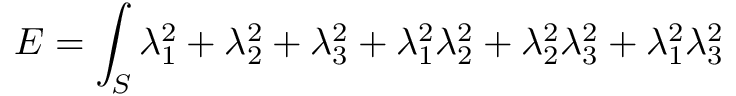Convert formula to latex. <formula><loc_0><loc_0><loc_500><loc_500>E = \int _ { S } \lambda _ { 1 } ^ { 2 } + \lambda _ { 2 } ^ { 2 } + \lambda _ { 3 } ^ { 2 } + \lambda _ { 1 } ^ { 2 } \lambda _ { 2 } ^ { 2 } + \lambda _ { 2 } ^ { 2 } \lambda _ { 3 } ^ { 2 } + \lambda _ { 1 } ^ { 2 } \lambda _ { 3 } ^ { 2 }</formula> 